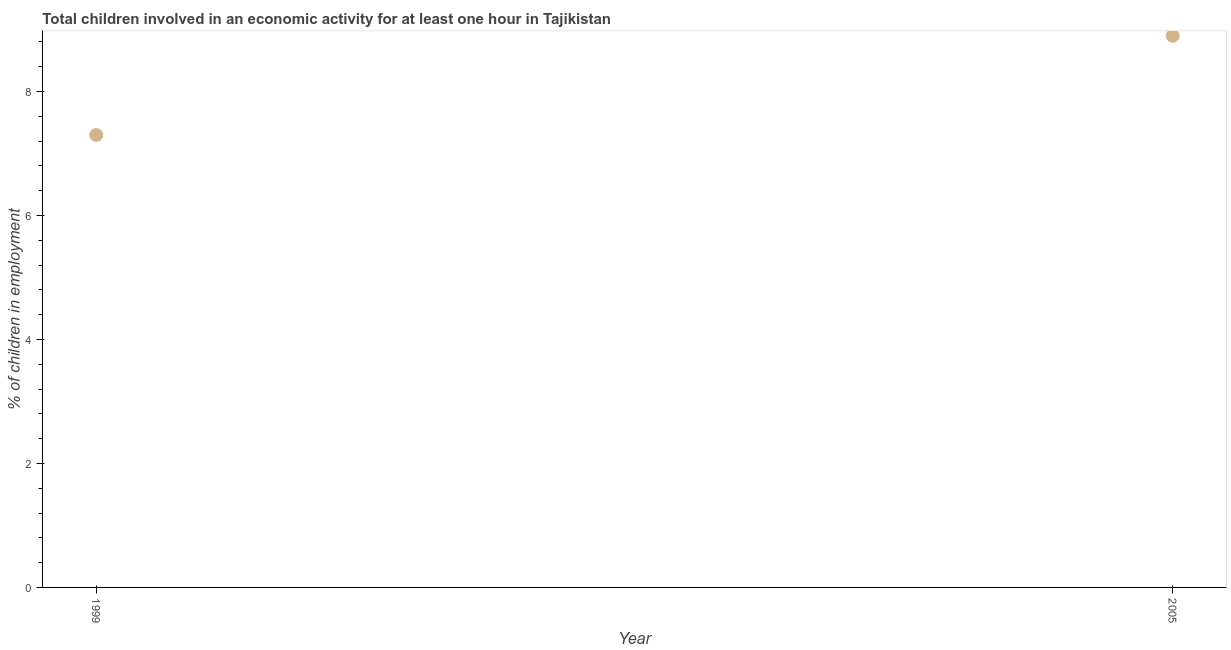What is the percentage of children in employment in 1999?
Provide a short and direct response. 7.3. In which year was the percentage of children in employment maximum?
Keep it short and to the point. 2005. In which year was the percentage of children in employment minimum?
Your response must be concise. 1999. What is the difference between the percentage of children in employment in 1999 and 2005?
Offer a very short reply. -1.6. Do a majority of the years between 1999 and 2005 (inclusive) have percentage of children in employment greater than 0.8 %?
Provide a succinct answer. Yes. What is the ratio of the percentage of children in employment in 1999 to that in 2005?
Make the answer very short. 0.82. Does the percentage of children in employment monotonically increase over the years?
Your response must be concise. Yes. How many dotlines are there?
Make the answer very short. 1. What is the difference between two consecutive major ticks on the Y-axis?
Provide a succinct answer. 2. Are the values on the major ticks of Y-axis written in scientific E-notation?
Offer a very short reply. No. Does the graph contain grids?
Keep it short and to the point. No. What is the title of the graph?
Your response must be concise. Total children involved in an economic activity for at least one hour in Tajikistan. What is the label or title of the Y-axis?
Your response must be concise. % of children in employment. What is the % of children in employment in 2005?
Provide a succinct answer. 8.9. What is the difference between the % of children in employment in 1999 and 2005?
Your response must be concise. -1.6. What is the ratio of the % of children in employment in 1999 to that in 2005?
Make the answer very short. 0.82. 